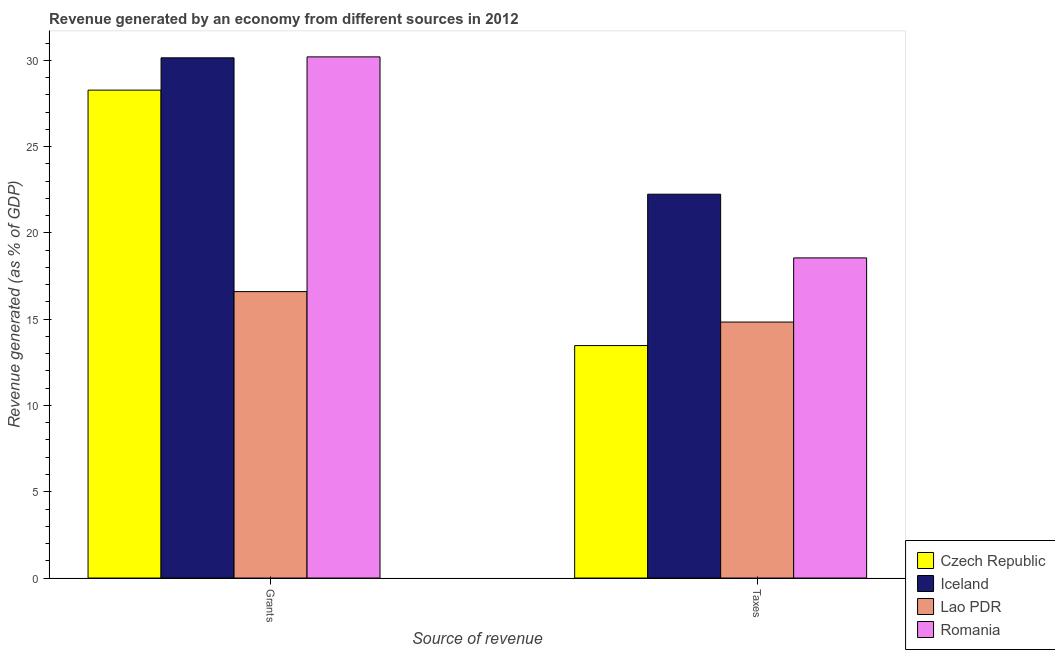How many groups of bars are there?
Give a very brief answer. 2. Are the number of bars per tick equal to the number of legend labels?
Ensure brevity in your answer.  Yes. How many bars are there on the 2nd tick from the left?
Offer a very short reply. 4. How many bars are there on the 1st tick from the right?
Keep it short and to the point. 4. What is the label of the 1st group of bars from the left?
Offer a very short reply. Grants. What is the revenue generated by taxes in Czech Republic?
Give a very brief answer. 13.47. Across all countries, what is the maximum revenue generated by taxes?
Provide a succinct answer. 22.24. Across all countries, what is the minimum revenue generated by grants?
Provide a succinct answer. 16.6. In which country was the revenue generated by grants minimum?
Keep it short and to the point. Lao PDR. What is the total revenue generated by grants in the graph?
Provide a short and direct response. 105.21. What is the difference between the revenue generated by grants in Lao PDR and that in Iceland?
Provide a short and direct response. -13.54. What is the difference between the revenue generated by grants in Iceland and the revenue generated by taxes in Czech Republic?
Make the answer very short. 16.67. What is the average revenue generated by taxes per country?
Provide a short and direct response. 17.27. What is the difference between the revenue generated by taxes and revenue generated by grants in Iceland?
Give a very brief answer. -7.9. What is the ratio of the revenue generated by taxes in Czech Republic to that in Iceland?
Offer a terse response. 0.61. Is the revenue generated by grants in Lao PDR less than that in Czech Republic?
Provide a short and direct response. Yes. What does the 1st bar from the left in Taxes represents?
Give a very brief answer. Czech Republic. What does the 2nd bar from the right in Grants represents?
Your answer should be very brief. Lao PDR. Are all the bars in the graph horizontal?
Ensure brevity in your answer.  No. How many countries are there in the graph?
Give a very brief answer. 4. Does the graph contain grids?
Provide a succinct answer. No. How many legend labels are there?
Make the answer very short. 4. How are the legend labels stacked?
Ensure brevity in your answer.  Vertical. What is the title of the graph?
Provide a succinct answer. Revenue generated by an economy from different sources in 2012. Does "French Polynesia" appear as one of the legend labels in the graph?
Make the answer very short. No. What is the label or title of the X-axis?
Give a very brief answer. Source of revenue. What is the label or title of the Y-axis?
Your answer should be compact. Revenue generated (as % of GDP). What is the Revenue generated (as % of GDP) of Czech Republic in Grants?
Keep it short and to the point. 28.27. What is the Revenue generated (as % of GDP) in Iceland in Grants?
Offer a very short reply. 30.14. What is the Revenue generated (as % of GDP) in Lao PDR in Grants?
Provide a succinct answer. 16.6. What is the Revenue generated (as % of GDP) of Romania in Grants?
Your answer should be very brief. 30.2. What is the Revenue generated (as % of GDP) of Czech Republic in Taxes?
Keep it short and to the point. 13.47. What is the Revenue generated (as % of GDP) in Iceland in Taxes?
Provide a short and direct response. 22.24. What is the Revenue generated (as % of GDP) of Lao PDR in Taxes?
Provide a succinct answer. 14.83. What is the Revenue generated (as % of GDP) of Romania in Taxes?
Your answer should be compact. 18.55. Across all Source of revenue, what is the maximum Revenue generated (as % of GDP) in Czech Republic?
Ensure brevity in your answer.  28.27. Across all Source of revenue, what is the maximum Revenue generated (as % of GDP) of Iceland?
Ensure brevity in your answer.  30.14. Across all Source of revenue, what is the maximum Revenue generated (as % of GDP) in Lao PDR?
Make the answer very short. 16.6. Across all Source of revenue, what is the maximum Revenue generated (as % of GDP) in Romania?
Keep it short and to the point. 30.2. Across all Source of revenue, what is the minimum Revenue generated (as % of GDP) of Czech Republic?
Give a very brief answer. 13.47. Across all Source of revenue, what is the minimum Revenue generated (as % of GDP) of Iceland?
Your response must be concise. 22.24. Across all Source of revenue, what is the minimum Revenue generated (as % of GDP) in Lao PDR?
Provide a succinct answer. 14.83. Across all Source of revenue, what is the minimum Revenue generated (as % of GDP) of Romania?
Give a very brief answer. 18.55. What is the total Revenue generated (as % of GDP) in Czech Republic in the graph?
Offer a terse response. 41.74. What is the total Revenue generated (as % of GDP) of Iceland in the graph?
Keep it short and to the point. 52.38. What is the total Revenue generated (as % of GDP) of Lao PDR in the graph?
Provide a short and direct response. 31.43. What is the total Revenue generated (as % of GDP) of Romania in the graph?
Your response must be concise. 48.75. What is the difference between the Revenue generated (as % of GDP) in Czech Republic in Grants and that in Taxes?
Your answer should be compact. 14.8. What is the difference between the Revenue generated (as % of GDP) of Iceland in Grants and that in Taxes?
Your answer should be very brief. 7.9. What is the difference between the Revenue generated (as % of GDP) in Lao PDR in Grants and that in Taxes?
Your response must be concise. 1.77. What is the difference between the Revenue generated (as % of GDP) in Romania in Grants and that in Taxes?
Provide a short and direct response. 11.65. What is the difference between the Revenue generated (as % of GDP) of Czech Republic in Grants and the Revenue generated (as % of GDP) of Iceland in Taxes?
Your answer should be very brief. 6.03. What is the difference between the Revenue generated (as % of GDP) in Czech Republic in Grants and the Revenue generated (as % of GDP) in Lao PDR in Taxes?
Ensure brevity in your answer.  13.44. What is the difference between the Revenue generated (as % of GDP) in Czech Republic in Grants and the Revenue generated (as % of GDP) in Romania in Taxes?
Keep it short and to the point. 9.72. What is the difference between the Revenue generated (as % of GDP) in Iceland in Grants and the Revenue generated (as % of GDP) in Lao PDR in Taxes?
Ensure brevity in your answer.  15.31. What is the difference between the Revenue generated (as % of GDP) in Iceland in Grants and the Revenue generated (as % of GDP) in Romania in Taxes?
Make the answer very short. 11.59. What is the difference between the Revenue generated (as % of GDP) in Lao PDR in Grants and the Revenue generated (as % of GDP) in Romania in Taxes?
Your answer should be compact. -1.95. What is the average Revenue generated (as % of GDP) of Czech Republic per Source of revenue?
Keep it short and to the point. 20.87. What is the average Revenue generated (as % of GDP) in Iceland per Source of revenue?
Provide a succinct answer. 26.19. What is the average Revenue generated (as % of GDP) in Lao PDR per Source of revenue?
Ensure brevity in your answer.  15.71. What is the average Revenue generated (as % of GDP) of Romania per Source of revenue?
Ensure brevity in your answer.  24.37. What is the difference between the Revenue generated (as % of GDP) of Czech Republic and Revenue generated (as % of GDP) of Iceland in Grants?
Offer a very short reply. -1.87. What is the difference between the Revenue generated (as % of GDP) of Czech Republic and Revenue generated (as % of GDP) of Lao PDR in Grants?
Give a very brief answer. 11.67. What is the difference between the Revenue generated (as % of GDP) in Czech Republic and Revenue generated (as % of GDP) in Romania in Grants?
Your answer should be very brief. -1.93. What is the difference between the Revenue generated (as % of GDP) of Iceland and Revenue generated (as % of GDP) of Lao PDR in Grants?
Keep it short and to the point. 13.54. What is the difference between the Revenue generated (as % of GDP) of Iceland and Revenue generated (as % of GDP) of Romania in Grants?
Keep it short and to the point. -0.05. What is the difference between the Revenue generated (as % of GDP) in Lao PDR and Revenue generated (as % of GDP) in Romania in Grants?
Offer a very short reply. -13.6. What is the difference between the Revenue generated (as % of GDP) in Czech Republic and Revenue generated (as % of GDP) in Iceland in Taxes?
Provide a succinct answer. -8.77. What is the difference between the Revenue generated (as % of GDP) in Czech Republic and Revenue generated (as % of GDP) in Lao PDR in Taxes?
Your answer should be compact. -1.36. What is the difference between the Revenue generated (as % of GDP) of Czech Republic and Revenue generated (as % of GDP) of Romania in Taxes?
Ensure brevity in your answer.  -5.08. What is the difference between the Revenue generated (as % of GDP) of Iceland and Revenue generated (as % of GDP) of Lao PDR in Taxes?
Provide a short and direct response. 7.41. What is the difference between the Revenue generated (as % of GDP) of Iceland and Revenue generated (as % of GDP) of Romania in Taxes?
Keep it short and to the point. 3.69. What is the difference between the Revenue generated (as % of GDP) of Lao PDR and Revenue generated (as % of GDP) of Romania in Taxes?
Make the answer very short. -3.72. What is the ratio of the Revenue generated (as % of GDP) of Czech Republic in Grants to that in Taxes?
Provide a short and direct response. 2.1. What is the ratio of the Revenue generated (as % of GDP) in Iceland in Grants to that in Taxes?
Make the answer very short. 1.36. What is the ratio of the Revenue generated (as % of GDP) in Lao PDR in Grants to that in Taxes?
Keep it short and to the point. 1.12. What is the ratio of the Revenue generated (as % of GDP) of Romania in Grants to that in Taxes?
Provide a short and direct response. 1.63. What is the difference between the highest and the second highest Revenue generated (as % of GDP) in Czech Republic?
Offer a very short reply. 14.8. What is the difference between the highest and the second highest Revenue generated (as % of GDP) in Iceland?
Your response must be concise. 7.9. What is the difference between the highest and the second highest Revenue generated (as % of GDP) of Lao PDR?
Offer a very short reply. 1.77. What is the difference between the highest and the second highest Revenue generated (as % of GDP) of Romania?
Provide a short and direct response. 11.65. What is the difference between the highest and the lowest Revenue generated (as % of GDP) in Czech Republic?
Provide a short and direct response. 14.8. What is the difference between the highest and the lowest Revenue generated (as % of GDP) in Iceland?
Give a very brief answer. 7.9. What is the difference between the highest and the lowest Revenue generated (as % of GDP) in Lao PDR?
Your answer should be compact. 1.77. What is the difference between the highest and the lowest Revenue generated (as % of GDP) in Romania?
Provide a short and direct response. 11.65. 